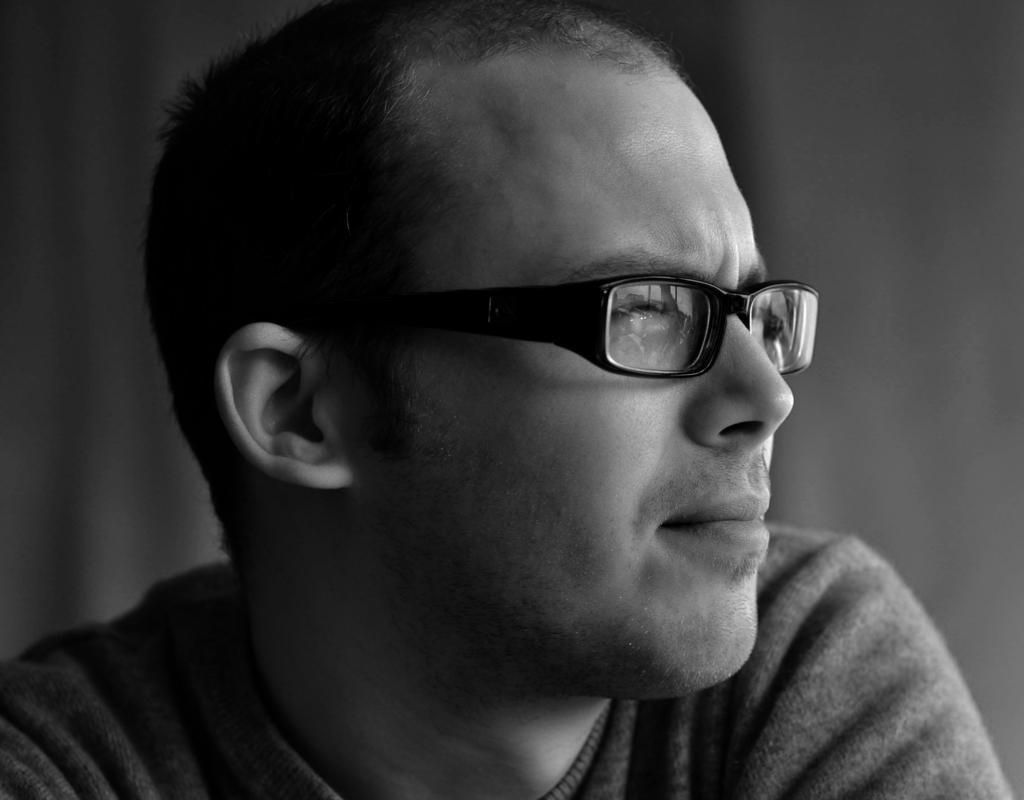Can you describe this image briefly? In this image we can see a person wearing spects. 